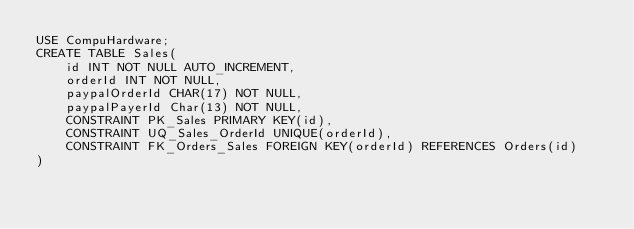Convert code to text. <code><loc_0><loc_0><loc_500><loc_500><_SQL_>USE CompuHardware;
CREATE TABLE Sales(
	id INT NOT NULL AUTO_INCREMENT,
    orderId INT NOT NULL,
    paypalOrderId CHAR(17) NOT NULL,
    paypalPayerId Char(13) NOT NULL,
    CONSTRAINT PK_Sales PRIMARY KEY(id),
    CONSTRAINT UQ_Sales_OrderId UNIQUE(orderId),
    CONSTRAINT FK_Orders_Sales FOREIGN KEY(orderId) REFERENCES Orders(id)
)

</code> 